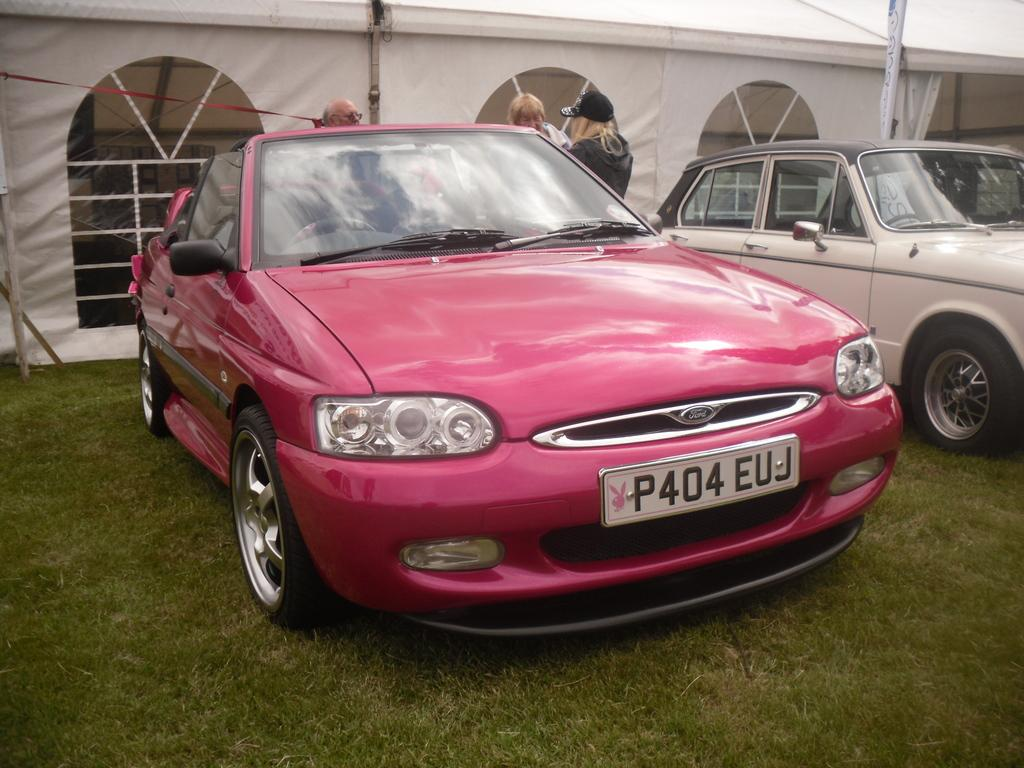Provide a one-sentence caption for the provided image. A hot pink Ford convertible sits outside a white tent. 